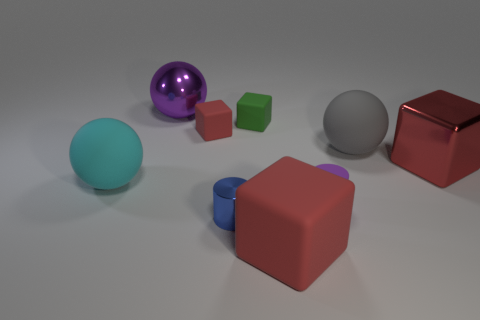Subtract all purple balls. How many red cubes are left? 3 Subtract all spheres. How many objects are left? 6 Add 5 large cyan matte objects. How many large cyan matte objects exist? 6 Subtract 0 green balls. How many objects are left? 9 Subtract all small purple objects. Subtract all purple cubes. How many objects are left? 8 Add 9 small rubber cylinders. How many small rubber cylinders are left? 10 